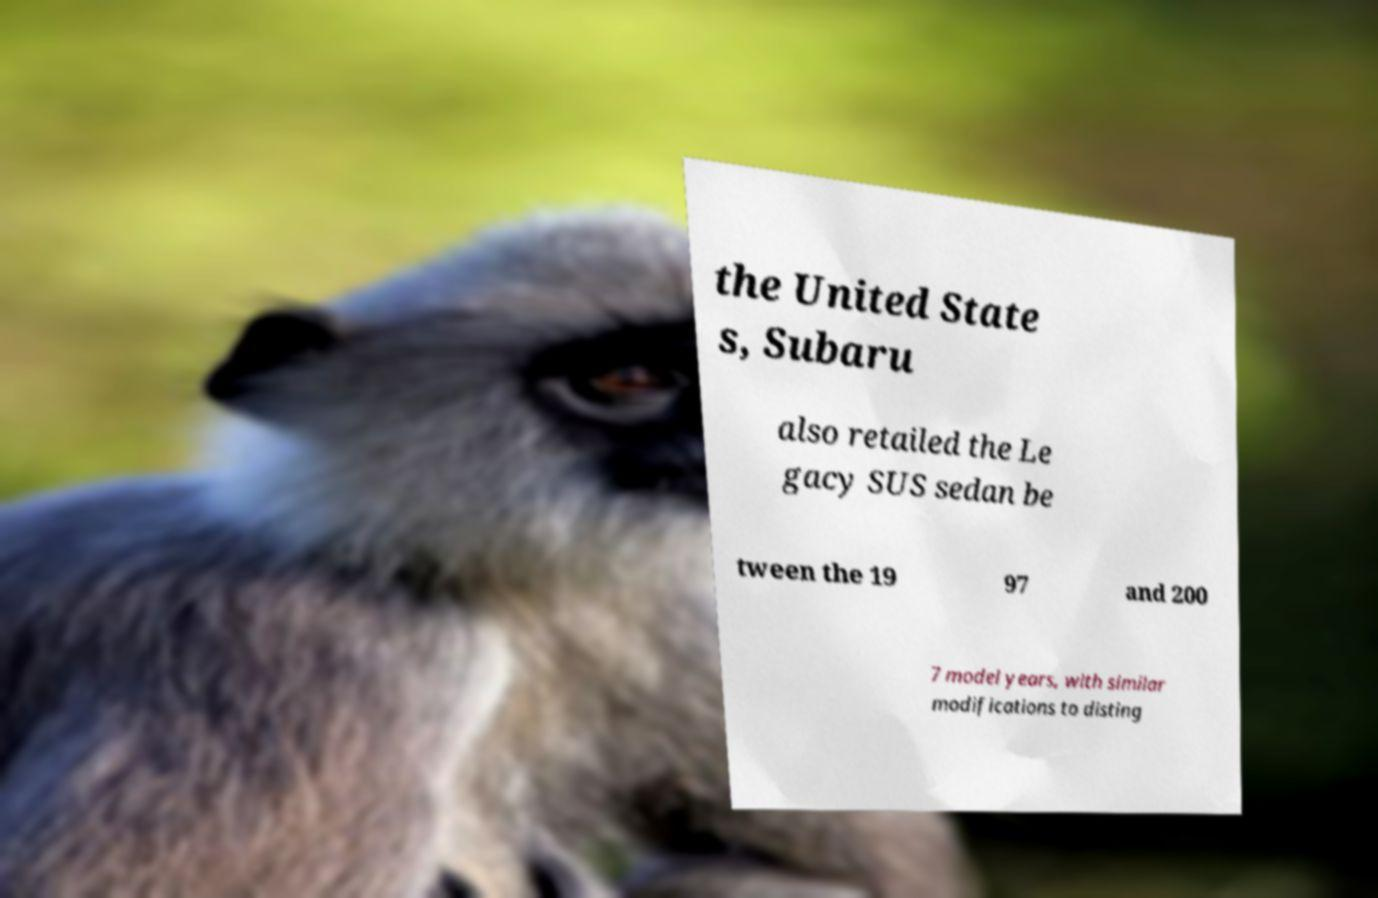What messages or text are displayed in this image? I need them in a readable, typed format. the United State s, Subaru also retailed the Le gacy SUS sedan be tween the 19 97 and 200 7 model years, with similar modifications to disting 